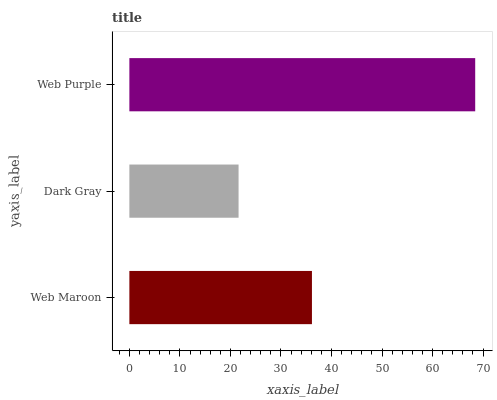Is Dark Gray the minimum?
Answer yes or no. Yes. Is Web Purple the maximum?
Answer yes or no. Yes. Is Web Purple the minimum?
Answer yes or no. No. Is Dark Gray the maximum?
Answer yes or no. No. Is Web Purple greater than Dark Gray?
Answer yes or no. Yes. Is Dark Gray less than Web Purple?
Answer yes or no. Yes. Is Dark Gray greater than Web Purple?
Answer yes or no. No. Is Web Purple less than Dark Gray?
Answer yes or no. No. Is Web Maroon the high median?
Answer yes or no. Yes. Is Web Maroon the low median?
Answer yes or no. Yes. Is Web Purple the high median?
Answer yes or no. No. Is Web Purple the low median?
Answer yes or no. No. 